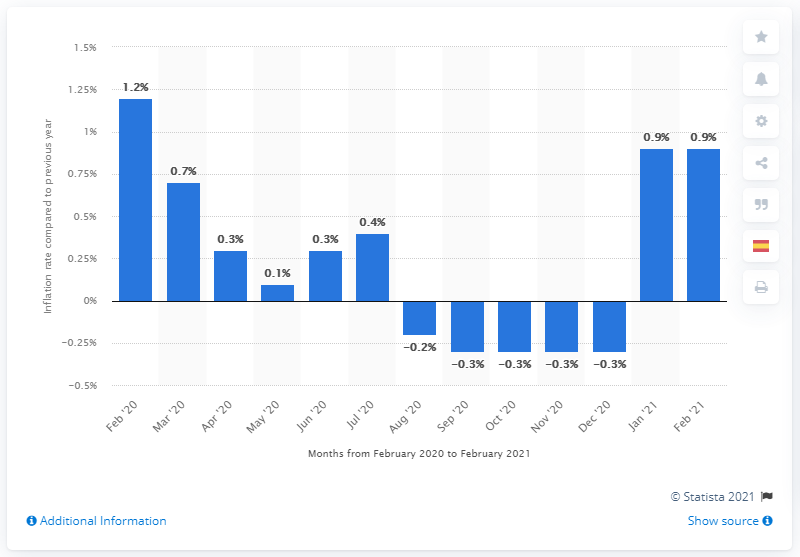Give some essential details in this illustration. In February 2021, the inflation rate in the Euro area was 0.9%. 